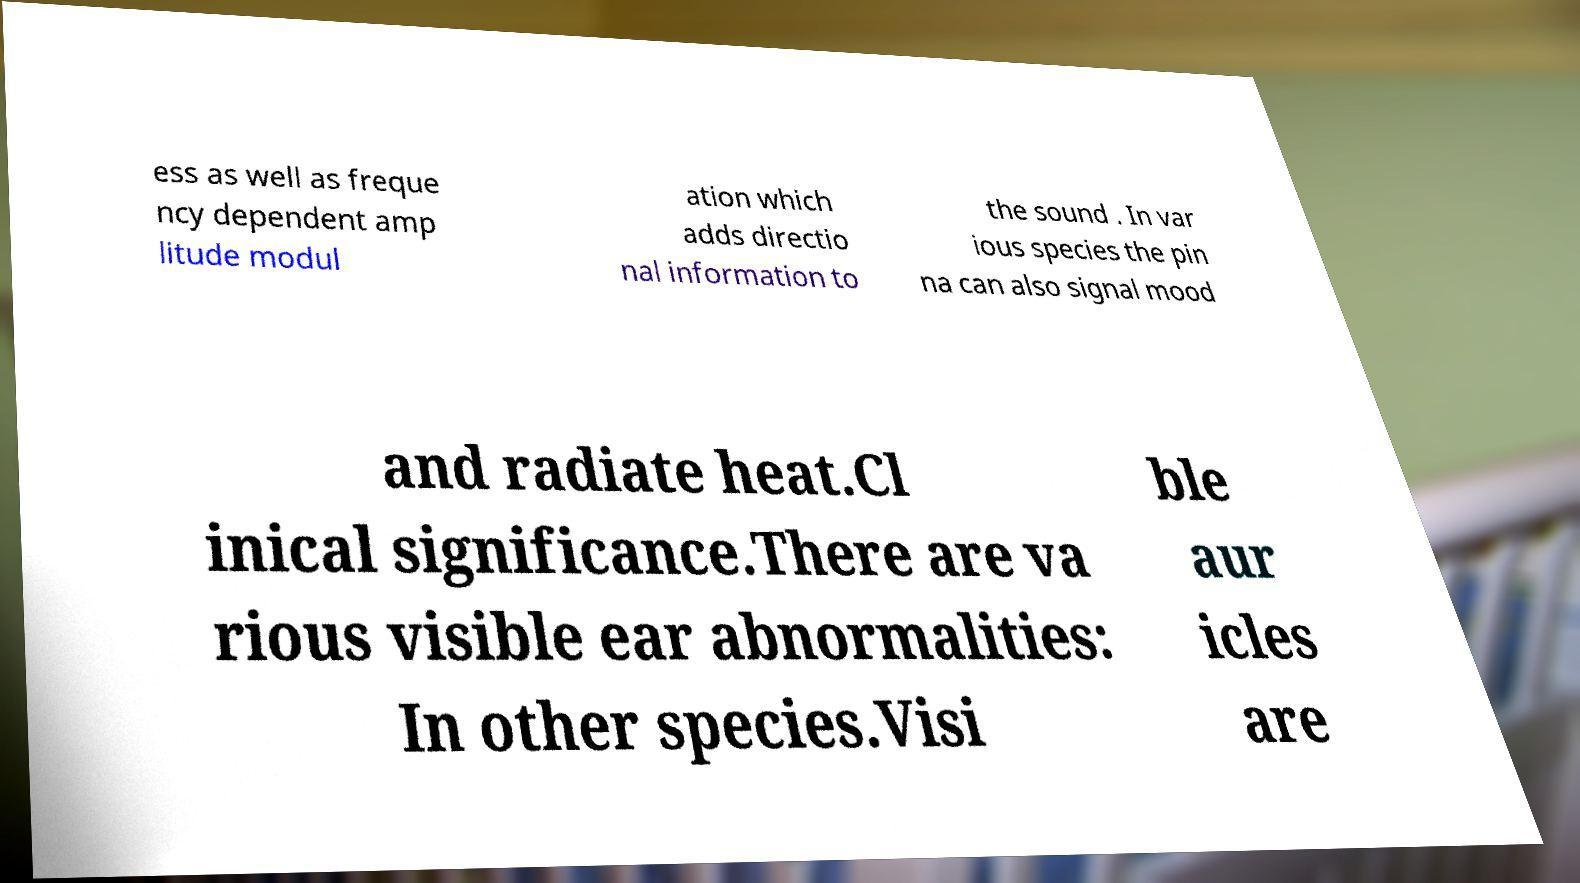Please read and relay the text visible in this image. What does it say? ess as well as freque ncy dependent amp litude modul ation which adds directio nal information to the sound . In var ious species the pin na can also signal mood and radiate heat.Cl inical significance.There are va rious visible ear abnormalities: In other species.Visi ble aur icles are 